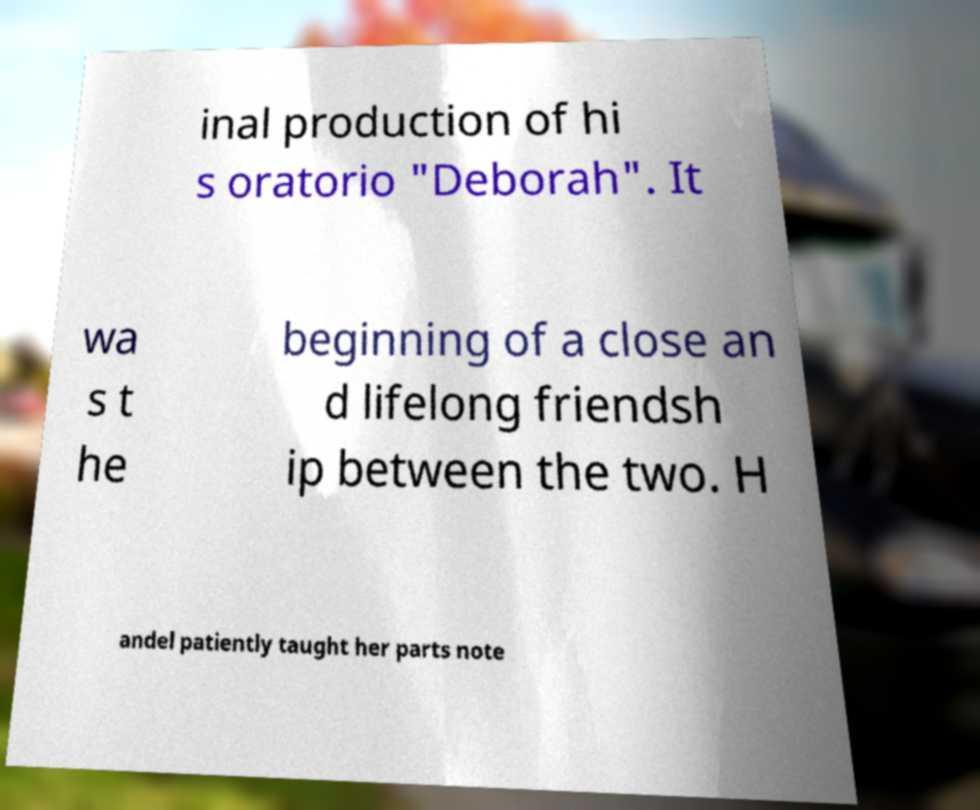Please identify and transcribe the text found in this image. inal production of hi s oratorio "Deborah". It wa s t he beginning of a close an d lifelong friendsh ip between the two. H andel patiently taught her parts note 